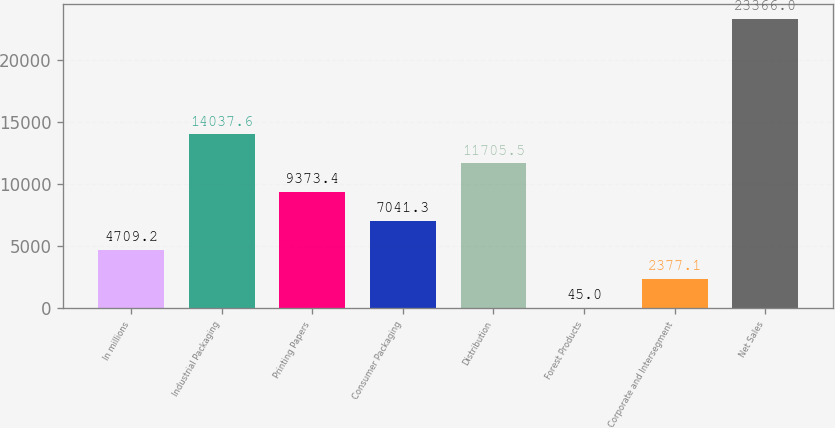Convert chart. <chart><loc_0><loc_0><loc_500><loc_500><bar_chart><fcel>In millions<fcel>Industrial Packaging<fcel>Printing Papers<fcel>Consumer Packaging<fcel>Distribution<fcel>Forest Products<fcel>Corporate and Intersegment<fcel>Net Sales<nl><fcel>4709.2<fcel>14037.6<fcel>9373.4<fcel>7041.3<fcel>11705.5<fcel>45<fcel>2377.1<fcel>23366<nl></chart> 